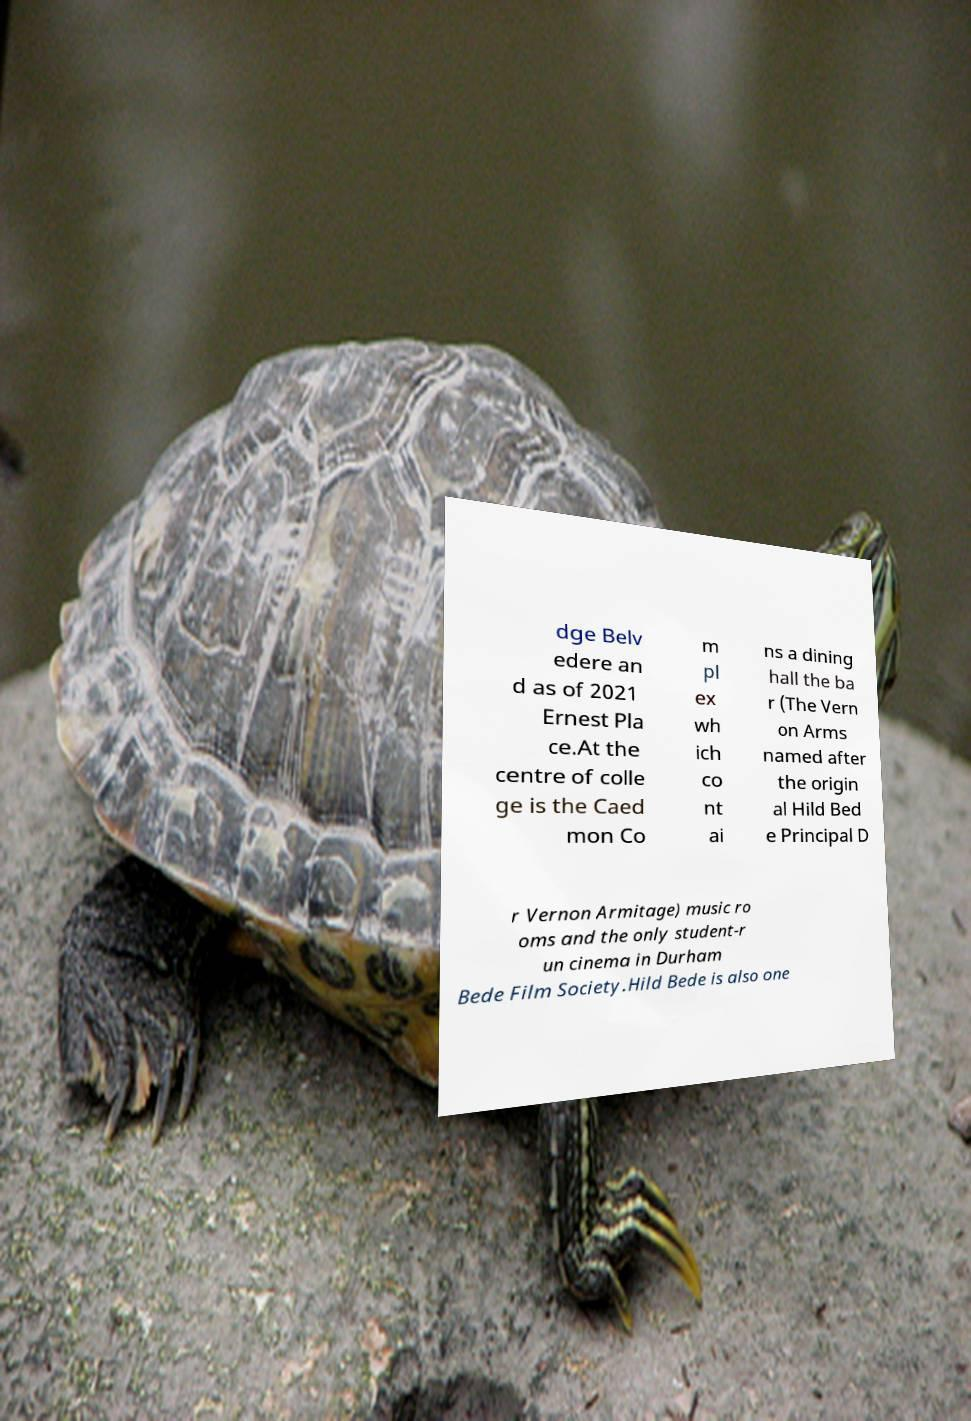Could you assist in decoding the text presented in this image and type it out clearly? dge Belv edere an d as of 2021 Ernest Pla ce.At the centre of colle ge is the Caed mon Co m pl ex wh ich co nt ai ns a dining hall the ba r (The Vern on Arms named after the origin al Hild Bed e Principal D r Vernon Armitage) music ro oms and the only student-r un cinema in Durham Bede Film Society.Hild Bede is also one 